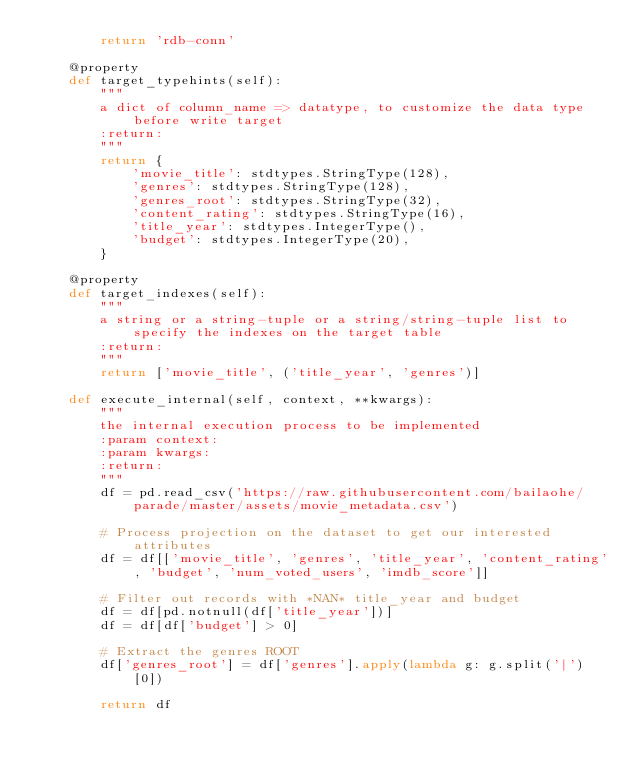<code> <loc_0><loc_0><loc_500><loc_500><_Python_>        return 'rdb-conn'

    @property
    def target_typehints(self):
        """
        a dict of column_name => datatype, to customize the data type before write target
        :return:
        """
        return {
            'movie_title': stdtypes.StringType(128),
            'genres': stdtypes.StringType(128),
            'genres_root': stdtypes.StringType(32),
            'content_rating': stdtypes.StringType(16),
            'title_year': stdtypes.IntegerType(),
            'budget': stdtypes.IntegerType(20),
        }

    @property
    def target_indexes(self):
        """
        a string or a string-tuple or a string/string-tuple list to specify the indexes on the target table
        :return:
        """
        return ['movie_title', ('title_year', 'genres')]

    def execute_internal(self, context, **kwargs):
        """
        the internal execution process to be implemented
        :param context:
        :param kwargs:
        :return:
        """
        df = pd.read_csv('https://raw.githubusercontent.com/bailaohe/parade/master/assets/movie_metadata.csv')

        # Process projection on the dataset to get our interested attributes
        df = df[['movie_title', 'genres', 'title_year', 'content_rating', 'budget', 'num_voted_users', 'imdb_score']]

        # Filter out records with *NAN* title_year and budget
        df = df[pd.notnull(df['title_year'])]
        df = df[df['budget'] > 0]

        # Extract the genres ROOT
        df['genres_root'] = df['genres'].apply(lambda g: g.split('|')[0])

        return df

</code> 